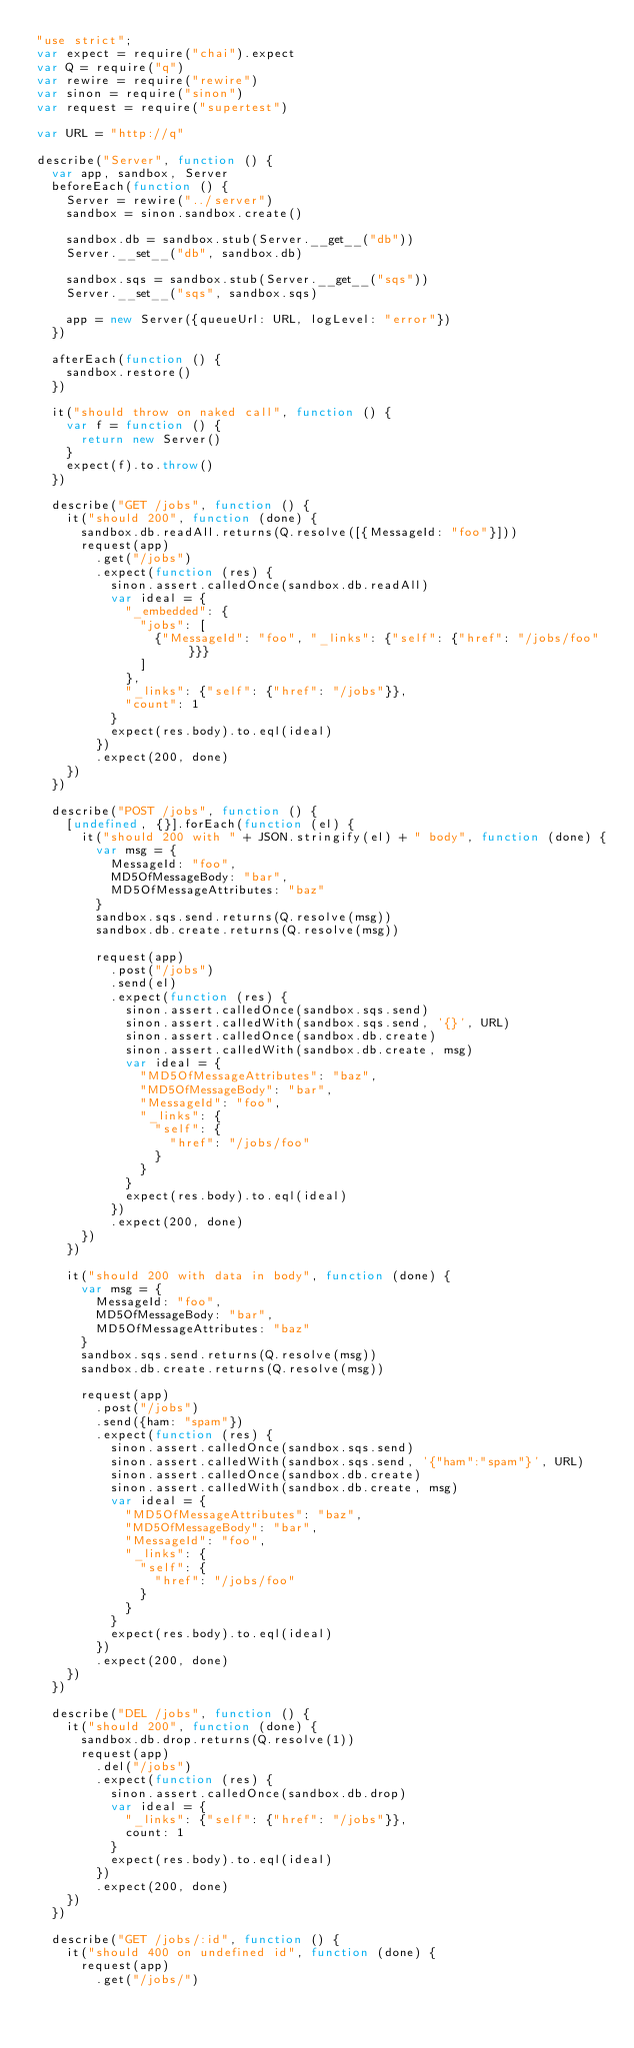Convert code to text. <code><loc_0><loc_0><loc_500><loc_500><_JavaScript_>"use strict";
var expect = require("chai").expect
var Q = require("q")
var rewire = require("rewire")
var sinon = require("sinon")
var request = require("supertest")

var URL = "http://q"

describe("Server", function () {
  var app, sandbox, Server
  beforeEach(function () {
    Server = rewire("../server")
    sandbox = sinon.sandbox.create()

    sandbox.db = sandbox.stub(Server.__get__("db"))
    Server.__set__("db", sandbox.db)

    sandbox.sqs = sandbox.stub(Server.__get__("sqs"))
    Server.__set__("sqs", sandbox.sqs)

    app = new Server({queueUrl: URL, logLevel: "error"})
  })

  afterEach(function () {
    sandbox.restore()
  })

  it("should throw on naked call", function () {
    var f = function () {
      return new Server()
    }
    expect(f).to.throw()
  })

  describe("GET /jobs", function () {
    it("should 200", function (done) {
      sandbox.db.readAll.returns(Q.resolve([{MessageId: "foo"}]))
      request(app)
        .get("/jobs")
        .expect(function (res) {
          sinon.assert.calledOnce(sandbox.db.readAll)
          var ideal = {
            "_embedded": {
              "jobs": [
                {"MessageId": "foo", "_links": {"self": {"href": "/jobs/foo"}}}
              ]
            },
            "_links": {"self": {"href": "/jobs"}},
            "count": 1
          }
          expect(res.body).to.eql(ideal)
        })
        .expect(200, done)
    })
  })

  describe("POST /jobs", function () {
    [undefined, {}].forEach(function (el) {
      it("should 200 with " + JSON.stringify(el) + " body", function (done) {
        var msg = {
          MessageId: "foo",
          MD5OfMessageBody: "bar",
          MD5OfMessageAttributes: "baz"
        }
        sandbox.sqs.send.returns(Q.resolve(msg))
        sandbox.db.create.returns(Q.resolve(msg))

        request(app)
          .post("/jobs")
          .send(el)
          .expect(function (res) {
            sinon.assert.calledOnce(sandbox.sqs.send)
            sinon.assert.calledWith(sandbox.sqs.send, '{}', URL)
            sinon.assert.calledOnce(sandbox.db.create)
            sinon.assert.calledWith(sandbox.db.create, msg)
            var ideal = {
              "MD5OfMessageAttributes": "baz",
              "MD5OfMessageBody": "bar",
              "MessageId": "foo",
              "_links": {
                "self": {
                  "href": "/jobs/foo"
                }
              }
            }
            expect(res.body).to.eql(ideal)
          })
          .expect(200, done)
      })
    })

    it("should 200 with data in body", function (done) {
      var msg = {
        MessageId: "foo",
        MD5OfMessageBody: "bar",
        MD5OfMessageAttributes: "baz"
      }
      sandbox.sqs.send.returns(Q.resolve(msg))
      sandbox.db.create.returns(Q.resolve(msg))

      request(app)
        .post("/jobs")
        .send({ham: "spam"})
        .expect(function (res) {
          sinon.assert.calledOnce(sandbox.sqs.send)
          sinon.assert.calledWith(sandbox.sqs.send, '{"ham":"spam"}', URL)
          sinon.assert.calledOnce(sandbox.db.create)
          sinon.assert.calledWith(sandbox.db.create, msg)
          var ideal = {
            "MD5OfMessageAttributes": "baz",
            "MD5OfMessageBody": "bar",
            "MessageId": "foo",
            "_links": {
              "self": {
                "href": "/jobs/foo"
              }
            }
          }
          expect(res.body).to.eql(ideal)
        })
        .expect(200, done)
    })
  })

  describe("DEL /jobs", function () {
    it("should 200", function (done) {
      sandbox.db.drop.returns(Q.resolve(1))
      request(app)
        .del("/jobs")
        .expect(function (res) {
          sinon.assert.calledOnce(sandbox.db.drop)
          var ideal = {
            "_links": {"self": {"href": "/jobs"}},
            count: 1
          }
          expect(res.body).to.eql(ideal)
        })
        .expect(200, done)
    })
  })

  describe("GET /jobs/:id", function () {
    it("should 400 on undefined id", function (done) {
      request(app)
        .get("/jobs/")</code> 